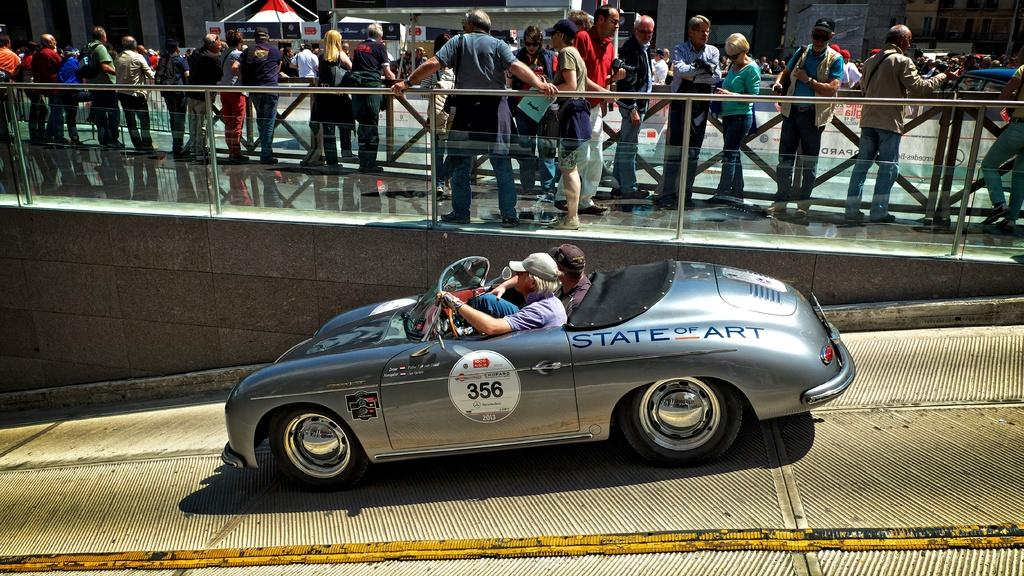What is happening with the two men in the image? The two men are sitting inside a car. What is the status of the car in the image? The car is in motion. What can be seen in the background of the image? There are people standing on a bridge. What are the people on the bridge doing? The people on the bridge are engaged in their own activities. How many wings can be seen on the cart in the image? There is no cart or wings present in the image. What time is displayed on the clocks in the image? There are no clocks present in the image. 